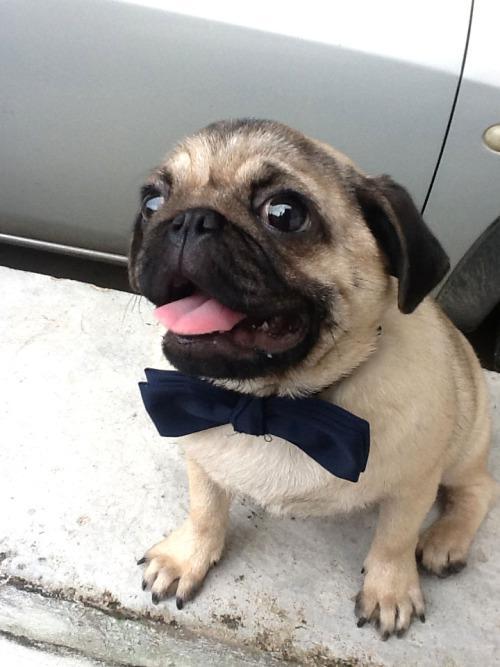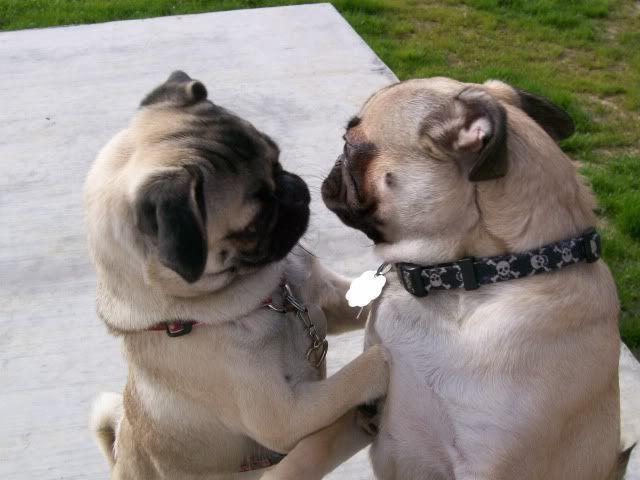The first image is the image on the left, the second image is the image on the right. For the images shown, is this caption "Two dogs are outside in the grass in the image on the right." true? Answer yes or no. No. The first image is the image on the left, the second image is the image on the right. Evaluate the accuracy of this statement regarding the images: "Two buff beige pugs with dark muzzles, at least one wearing a collar, are close together and face to face in the right image.". Is it true? Answer yes or no. Yes. 